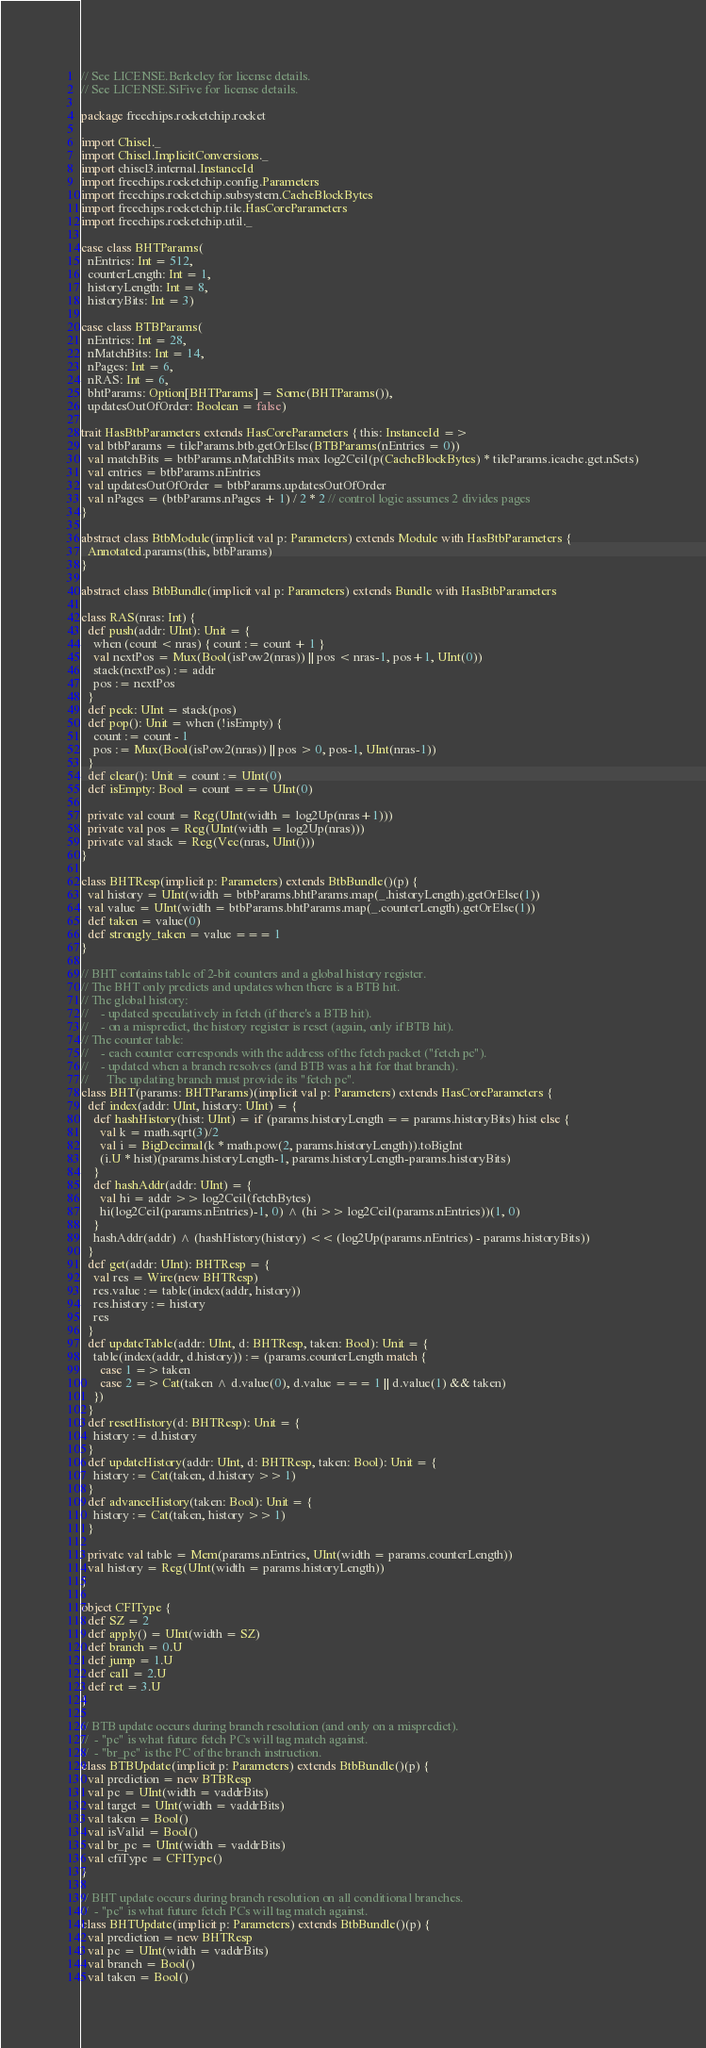<code> <loc_0><loc_0><loc_500><loc_500><_Scala_>// See LICENSE.Berkeley for license details.
// See LICENSE.SiFive for license details.

package freechips.rocketchip.rocket

import Chisel._
import Chisel.ImplicitConversions._
import chisel3.internal.InstanceId
import freechips.rocketchip.config.Parameters
import freechips.rocketchip.subsystem.CacheBlockBytes
import freechips.rocketchip.tile.HasCoreParameters
import freechips.rocketchip.util._

case class BHTParams(
  nEntries: Int = 512,
  counterLength: Int = 1,
  historyLength: Int = 8,
  historyBits: Int = 3)

case class BTBParams(
  nEntries: Int = 28,
  nMatchBits: Int = 14,
  nPages: Int = 6,
  nRAS: Int = 6,
  bhtParams: Option[BHTParams] = Some(BHTParams()),
  updatesOutOfOrder: Boolean = false)

trait HasBtbParameters extends HasCoreParameters { this: InstanceId =>
  val btbParams = tileParams.btb.getOrElse(BTBParams(nEntries = 0))
  val matchBits = btbParams.nMatchBits max log2Ceil(p(CacheBlockBytes) * tileParams.icache.get.nSets)
  val entries = btbParams.nEntries
  val updatesOutOfOrder = btbParams.updatesOutOfOrder
  val nPages = (btbParams.nPages + 1) / 2 * 2 // control logic assumes 2 divides pages
}

abstract class BtbModule(implicit val p: Parameters) extends Module with HasBtbParameters {
  Annotated.params(this, btbParams)
}

abstract class BtbBundle(implicit val p: Parameters) extends Bundle with HasBtbParameters

class RAS(nras: Int) {
  def push(addr: UInt): Unit = {
    when (count < nras) { count := count + 1 }
    val nextPos = Mux(Bool(isPow2(nras)) || pos < nras-1, pos+1, UInt(0))
    stack(nextPos) := addr
    pos := nextPos
  }
  def peek: UInt = stack(pos)
  def pop(): Unit = when (!isEmpty) {
    count := count - 1
    pos := Mux(Bool(isPow2(nras)) || pos > 0, pos-1, UInt(nras-1))
  }
  def clear(): Unit = count := UInt(0)
  def isEmpty: Bool = count === UInt(0)

  private val count = Reg(UInt(width = log2Up(nras+1)))
  private val pos = Reg(UInt(width = log2Up(nras)))
  private val stack = Reg(Vec(nras, UInt()))
}

class BHTResp(implicit p: Parameters) extends BtbBundle()(p) {
  val history = UInt(width = btbParams.bhtParams.map(_.historyLength).getOrElse(1))
  val value = UInt(width = btbParams.bhtParams.map(_.counterLength).getOrElse(1))
  def taken = value(0)
  def strongly_taken = value === 1
}

// BHT contains table of 2-bit counters and a global history register.
// The BHT only predicts and updates when there is a BTB hit.
// The global history:
//    - updated speculatively in fetch (if there's a BTB hit).
//    - on a mispredict, the history register is reset (again, only if BTB hit).
// The counter table:
//    - each counter corresponds with the address of the fetch packet ("fetch pc").
//    - updated when a branch resolves (and BTB was a hit for that branch).
//      The updating branch must provide its "fetch pc".
class BHT(params: BHTParams)(implicit val p: Parameters) extends HasCoreParameters {
  def index(addr: UInt, history: UInt) = {
    def hashHistory(hist: UInt) = if (params.historyLength == params.historyBits) hist else {
      val k = math.sqrt(3)/2
      val i = BigDecimal(k * math.pow(2, params.historyLength)).toBigInt
      (i.U * hist)(params.historyLength-1, params.historyLength-params.historyBits)
    }
    def hashAddr(addr: UInt) = {
      val hi = addr >> log2Ceil(fetchBytes)
      hi(log2Ceil(params.nEntries)-1, 0) ^ (hi >> log2Ceil(params.nEntries))(1, 0)
    }
    hashAddr(addr) ^ (hashHistory(history) << (log2Up(params.nEntries) - params.historyBits))
  }
  def get(addr: UInt): BHTResp = {
    val res = Wire(new BHTResp)
    res.value := table(index(addr, history))
    res.history := history
    res
  }
  def updateTable(addr: UInt, d: BHTResp, taken: Bool): Unit = {
    table(index(addr, d.history)) := (params.counterLength match {
      case 1 => taken
      case 2 => Cat(taken ^ d.value(0), d.value === 1 || d.value(1) && taken)
    })
  }
  def resetHistory(d: BHTResp): Unit = {
    history := d.history
  }
  def updateHistory(addr: UInt, d: BHTResp, taken: Bool): Unit = {
    history := Cat(taken, d.history >> 1)
  }
  def advanceHistory(taken: Bool): Unit = {
    history := Cat(taken, history >> 1)
  }

  private val table = Mem(params.nEntries, UInt(width = params.counterLength))
  val history = Reg(UInt(width = params.historyLength))
}

object CFIType {
  def SZ = 2
  def apply() = UInt(width = SZ)
  def branch = 0.U
  def jump = 1.U
  def call = 2.U
  def ret = 3.U
}

// BTB update occurs during branch resolution (and only on a mispredict).
//  - "pc" is what future fetch PCs will tag match against.
//  - "br_pc" is the PC of the branch instruction.
class BTBUpdate(implicit p: Parameters) extends BtbBundle()(p) {
  val prediction = new BTBResp
  val pc = UInt(width = vaddrBits)
  val target = UInt(width = vaddrBits)
  val taken = Bool()
  val isValid = Bool()
  val br_pc = UInt(width = vaddrBits)
  val cfiType = CFIType()
}

// BHT update occurs during branch resolution on all conditional branches.
//  - "pc" is what future fetch PCs will tag match against.
class BHTUpdate(implicit p: Parameters) extends BtbBundle()(p) {
  val prediction = new BHTResp
  val pc = UInt(width = vaddrBits)
  val branch = Bool()
  val taken = Bool()</code> 